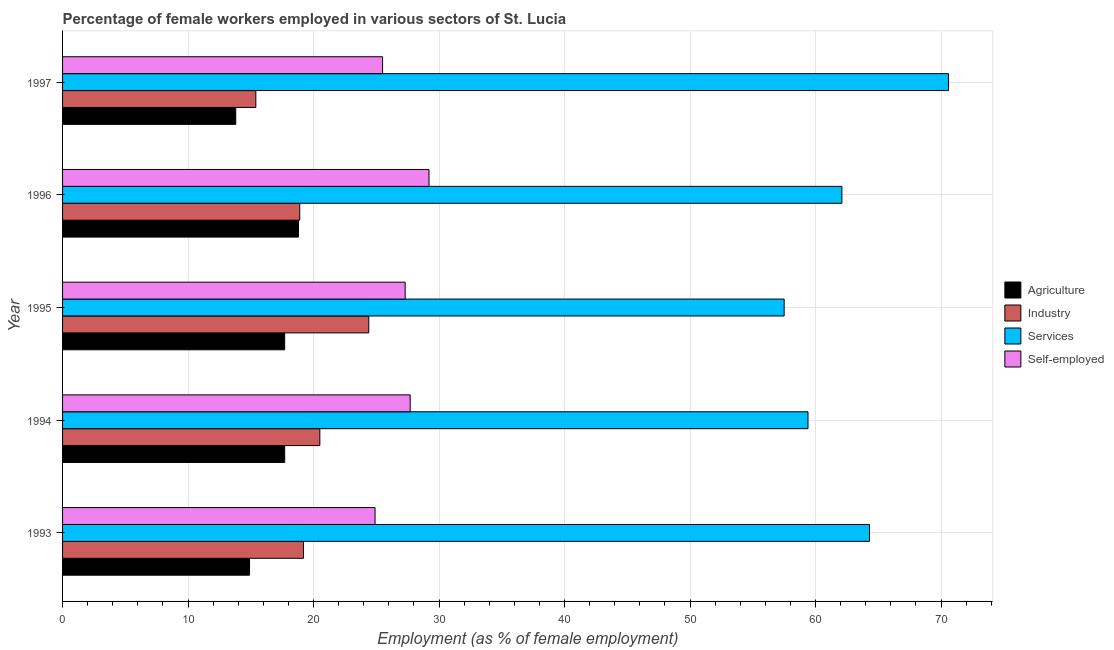How many different coloured bars are there?
Provide a succinct answer. 4. How many groups of bars are there?
Keep it short and to the point. 5. Are the number of bars on each tick of the Y-axis equal?
Your answer should be very brief. Yes. What is the percentage of female workers in services in 1993?
Provide a short and direct response. 64.3. Across all years, what is the maximum percentage of female workers in industry?
Provide a succinct answer. 24.4. Across all years, what is the minimum percentage of female workers in services?
Ensure brevity in your answer.  57.5. In which year was the percentage of self employed female workers maximum?
Your response must be concise. 1996. In which year was the percentage of self employed female workers minimum?
Ensure brevity in your answer.  1993. What is the total percentage of female workers in industry in the graph?
Offer a terse response. 98.4. What is the average percentage of female workers in agriculture per year?
Your response must be concise. 16.58. In the year 1993, what is the difference between the percentage of female workers in services and percentage of female workers in agriculture?
Provide a succinct answer. 49.4. In how many years, is the percentage of female workers in services greater than 40 %?
Your answer should be compact. 5. What is the ratio of the percentage of female workers in industry in 1994 to that in 1995?
Provide a succinct answer. 0.84. Is the percentage of self employed female workers in 1993 less than that in 1994?
Provide a succinct answer. Yes. Is the difference between the percentage of female workers in agriculture in 1993 and 1996 greater than the difference between the percentage of self employed female workers in 1993 and 1996?
Provide a succinct answer. Yes. What is the difference between the highest and the lowest percentage of self employed female workers?
Give a very brief answer. 4.3. In how many years, is the percentage of female workers in services greater than the average percentage of female workers in services taken over all years?
Provide a short and direct response. 2. Is the sum of the percentage of self employed female workers in 1994 and 1996 greater than the maximum percentage of female workers in agriculture across all years?
Give a very brief answer. Yes. Is it the case that in every year, the sum of the percentage of female workers in services and percentage of female workers in agriculture is greater than the sum of percentage of female workers in industry and percentage of self employed female workers?
Give a very brief answer. Yes. What does the 4th bar from the top in 1994 represents?
Offer a very short reply. Agriculture. What does the 2nd bar from the bottom in 1995 represents?
Offer a very short reply. Industry. Is it the case that in every year, the sum of the percentage of female workers in agriculture and percentage of female workers in industry is greater than the percentage of female workers in services?
Your response must be concise. No. How many bars are there?
Ensure brevity in your answer.  20. How many years are there in the graph?
Provide a short and direct response. 5. What is the difference between two consecutive major ticks on the X-axis?
Your response must be concise. 10. Are the values on the major ticks of X-axis written in scientific E-notation?
Provide a short and direct response. No. Does the graph contain grids?
Provide a succinct answer. Yes. Where does the legend appear in the graph?
Ensure brevity in your answer.  Center right. How many legend labels are there?
Keep it short and to the point. 4. How are the legend labels stacked?
Your response must be concise. Vertical. What is the title of the graph?
Offer a very short reply. Percentage of female workers employed in various sectors of St. Lucia. Does "Tracking ability" appear as one of the legend labels in the graph?
Give a very brief answer. No. What is the label or title of the X-axis?
Your answer should be compact. Employment (as % of female employment). What is the label or title of the Y-axis?
Ensure brevity in your answer.  Year. What is the Employment (as % of female employment) of Agriculture in 1993?
Provide a succinct answer. 14.9. What is the Employment (as % of female employment) in Industry in 1993?
Give a very brief answer. 19.2. What is the Employment (as % of female employment) of Services in 1993?
Offer a very short reply. 64.3. What is the Employment (as % of female employment) in Self-employed in 1993?
Give a very brief answer. 24.9. What is the Employment (as % of female employment) of Agriculture in 1994?
Your answer should be compact. 17.7. What is the Employment (as % of female employment) of Services in 1994?
Provide a succinct answer. 59.4. What is the Employment (as % of female employment) in Self-employed in 1994?
Keep it short and to the point. 27.7. What is the Employment (as % of female employment) of Agriculture in 1995?
Make the answer very short. 17.7. What is the Employment (as % of female employment) in Industry in 1995?
Provide a short and direct response. 24.4. What is the Employment (as % of female employment) in Services in 1995?
Give a very brief answer. 57.5. What is the Employment (as % of female employment) in Self-employed in 1995?
Give a very brief answer. 27.3. What is the Employment (as % of female employment) of Agriculture in 1996?
Provide a succinct answer. 18.8. What is the Employment (as % of female employment) of Industry in 1996?
Offer a very short reply. 18.9. What is the Employment (as % of female employment) in Services in 1996?
Give a very brief answer. 62.1. What is the Employment (as % of female employment) of Self-employed in 1996?
Ensure brevity in your answer.  29.2. What is the Employment (as % of female employment) in Agriculture in 1997?
Keep it short and to the point. 13.8. What is the Employment (as % of female employment) of Industry in 1997?
Ensure brevity in your answer.  15.4. What is the Employment (as % of female employment) in Services in 1997?
Your answer should be compact. 70.6. What is the Employment (as % of female employment) of Self-employed in 1997?
Ensure brevity in your answer.  25.5. Across all years, what is the maximum Employment (as % of female employment) in Agriculture?
Your answer should be compact. 18.8. Across all years, what is the maximum Employment (as % of female employment) in Industry?
Make the answer very short. 24.4. Across all years, what is the maximum Employment (as % of female employment) in Services?
Offer a terse response. 70.6. Across all years, what is the maximum Employment (as % of female employment) in Self-employed?
Offer a very short reply. 29.2. Across all years, what is the minimum Employment (as % of female employment) of Agriculture?
Ensure brevity in your answer.  13.8. Across all years, what is the minimum Employment (as % of female employment) in Industry?
Make the answer very short. 15.4. Across all years, what is the minimum Employment (as % of female employment) of Services?
Ensure brevity in your answer.  57.5. Across all years, what is the minimum Employment (as % of female employment) of Self-employed?
Ensure brevity in your answer.  24.9. What is the total Employment (as % of female employment) in Agriculture in the graph?
Your answer should be very brief. 82.9. What is the total Employment (as % of female employment) in Industry in the graph?
Offer a terse response. 98.4. What is the total Employment (as % of female employment) in Services in the graph?
Offer a terse response. 313.9. What is the total Employment (as % of female employment) in Self-employed in the graph?
Give a very brief answer. 134.6. What is the difference between the Employment (as % of female employment) in Agriculture in 1993 and that in 1994?
Your answer should be very brief. -2.8. What is the difference between the Employment (as % of female employment) of Services in 1993 and that in 1994?
Your answer should be very brief. 4.9. What is the difference between the Employment (as % of female employment) in Self-employed in 1993 and that in 1994?
Keep it short and to the point. -2.8. What is the difference between the Employment (as % of female employment) of Industry in 1993 and that in 1995?
Provide a short and direct response. -5.2. What is the difference between the Employment (as % of female employment) in Services in 1993 and that in 1995?
Your response must be concise. 6.8. What is the difference between the Employment (as % of female employment) in Self-employed in 1993 and that in 1995?
Offer a terse response. -2.4. What is the difference between the Employment (as % of female employment) of Agriculture in 1993 and that in 1996?
Your answer should be very brief. -3.9. What is the difference between the Employment (as % of female employment) in Services in 1993 and that in 1996?
Your response must be concise. 2.2. What is the difference between the Employment (as % of female employment) of Self-employed in 1993 and that in 1996?
Offer a very short reply. -4.3. What is the difference between the Employment (as % of female employment) in Agriculture in 1993 and that in 1997?
Your response must be concise. 1.1. What is the difference between the Employment (as % of female employment) of Services in 1993 and that in 1997?
Make the answer very short. -6.3. What is the difference between the Employment (as % of female employment) of Self-employed in 1993 and that in 1997?
Your answer should be compact. -0.6. What is the difference between the Employment (as % of female employment) in Industry in 1994 and that in 1995?
Keep it short and to the point. -3.9. What is the difference between the Employment (as % of female employment) of Services in 1994 and that in 1995?
Give a very brief answer. 1.9. What is the difference between the Employment (as % of female employment) of Self-employed in 1994 and that in 1995?
Your response must be concise. 0.4. What is the difference between the Employment (as % of female employment) in Agriculture in 1994 and that in 1996?
Your answer should be very brief. -1.1. What is the difference between the Employment (as % of female employment) of Industry in 1994 and that in 1996?
Ensure brevity in your answer.  1.6. What is the difference between the Employment (as % of female employment) of Agriculture in 1994 and that in 1997?
Ensure brevity in your answer.  3.9. What is the difference between the Employment (as % of female employment) of Industry in 1994 and that in 1997?
Your answer should be compact. 5.1. What is the difference between the Employment (as % of female employment) in Services in 1994 and that in 1997?
Offer a terse response. -11.2. What is the difference between the Employment (as % of female employment) of Self-employed in 1994 and that in 1997?
Provide a succinct answer. 2.2. What is the difference between the Employment (as % of female employment) of Agriculture in 1995 and that in 1996?
Your answer should be compact. -1.1. What is the difference between the Employment (as % of female employment) of Services in 1995 and that in 1996?
Offer a very short reply. -4.6. What is the difference between the Employment (as % of female employment) in Agriculture in 1995 and that in 1997?
Provide a short and direct response. 3.9. What is the difference between the Employment (as % of female employment) of Agriculture in 1993 and the Employment (as % of female employment) of Industry in 1994?
Your answer should be very brief. -5.6. What is the difference between the Employment (as % of female employment) of Agriculture in 1993 and the Employment (as % of female employment) of Services in 1994?
Your answer should be compact. -44.5. What is the difference between the Employment (as % of female employment) of Industry in 1993 and the Employment (as % of female employment) of Services in 1994?
Ensure brevity in your answer.  -40.2. What is the difference between the Employment (as % of female employment) of Industry in 1993 and the Employment (as % of female employment) of Self-employed in 1994?
Keep it short and to the point. -8.5. What is the difference between the Employment (as % of female employment) in Services in 1993 and the Employment (as % of female employment) in Self-employed in 1994?
Your answer should be very brief. 36.6. What is the difference between the Employment (as % of female employment) in Agriculture in 1993 and the Employment (as % of female employment) in Industry in 1995?
Give a very brief answer. -9.5. What is the difference between the Employment (as % of female employment) of Agriculture in 1993 and the Employment (as % of female employment) of Services in 1995?
Your answer should be compact. -42.6. What is the difference between the Employment (as % of female employment) in Industry in 1993 and the Employment (as % of female employment) in Services in 1995?
Offer a very short reply. -38.3. What is the difference between the Employment (as % of female employment) in Services in 1993 and the Employment (as % of female employment) in Self-employed in 1995?
Provide a short and direct response. 37. What is the difference between the Employment (as % of female employment) in Agriculture in 1993 and the Employment (as % of female employment) in Industry in 1996?
Ensure brevity in your answer.  -4. What is the difference between the Employment (as % of female employment) in Agriculture in 1993 and the Employment (as % of female employment) in Services in 1996?
Keep it short and to the point. -47.2. What is the difference between the Employment (as % of female employment) in Agriculture in 1993 and the Employment (as % of female employment) in Self-employed in 1996?
Make the answer very short. -14.3. What is the difference between the Employment (as % of female employment) in Industry in 1993 and the Employment (as % of female employment) in Services in 1996?
Make the answer very short. -42.9. What is the difference between the Employment (as % of female employment) in Industry in 1993 and the Employment (as % of female employment) in Self-employed in 1996?
Offer a very short reply. -10. What is the difference between the Employment (as % of female employment) of Services in 1993 and the Employment (as % of female employment) of Self-employed in 1996?
Your answer should be compact. 35.1. What is the difference between the Employment (as % of female employment) in Agriculture in 1993 and the Employment (as % of female employment) in Services in 1997?
Provide a succinct answer. -55.7. What is the difference between the Employment (as % of female employment) of Agriculture in 1993 and the Employment (as % of female employment) of Self-employed in 1997?
Your answer should be very brief. -10.6. What is the difference between the Employment (as % of female employment) in Industry in 1993 and the Employment (as % of female employment) in Services in 1997?
Ensure brevity in your answer.  -51.4. What is the difference between the Employment (as % of female employment) in Industry in 1993 and the Employment (as % of female employment) in Self-employed in 1997?
Keep it short and to the point. -6.3. What is the difference between the Employment (as % of female employment) in Services in 1993 and the Employment (as % of female employment) in Self-employed in 1997?
Your answer should be very brief. 38.8. What is the difference between the Employment (as % of female employment) of Agriculture in 1994 and the Employment (as % of female employment) of Industry in 1995?
Offer a terse response. -6.7. What is the difference between the Employment (as % of female employment) of Agriculture in 1994 and the Employment (as % of female employment) of Services in 1995?
Offer a very short reply. -39.8. What is the difference between the Employment (as % of female employment) of Industry in 1994 and the Employment (as % of female employment) of Services in 1995?
Provide a succinct answer. -37. What is the difference between the Employment (as % of female employment) of Services in 1994 and the Employment (as % of female employment) of Self-employed in 1995?
Your response must be concise. 32.1. What is the difference between the Employment (as % of female employment) of Agriculture in 1994 and the Employment (as % of female employment) of Services in 1996?
Provide a succinct answer. -44.4. What is the difference between the Employment (as % of female employment) of Agriculture in 1994 and the Employment (as % of female employment) of Self-employed in 1996?
Ensure brevity in your answer.  -11.5. What is the difference between the Employment (as % of female employment) of Industry in 1994 and the Employment (as % of female employment) of Services in 1996?
Offer a terse response. -41.6. What is the difference between the Employment (as % of female employment) of Services in 1994 and the Employment (as % of female employment) of Self-employed in 1996?
Ensure brevity in your answer.  30.2. What is the difference between the Employment (as % of female employment) of Agriculture in 1994 and the Employment (as % of female employment) of Services in 1997?
Keep it short and to the point. -52.9. What is the difference between the Employment (as % of female employment) in Industry in 1994 and the Employment (as % of female employment) in Services in 1997?
Make the answer very short. -50.1. What is the difference between the Employment (as % of female employment) of Industry in 1994 and the Employment (as % of female employment) of Self-employed in 1997?
Offer a terse response. -5. What is the difference between the Employment (as % of female employment) in Services in 1994 and the Employment (as % of female employment) in Self-employed in 1997?
Your answer should be compact. 33.9. What is the difference between the Employment (as % of female employment) of Agriculture in 1995 and the Employment (as % of female employment) of Services in 1996?
Ensure brevity in your answer.  -44.4. What is the difference between the Employment (as % of female employment) in Industry in 1995 and the Employment (as % of female employment) in Services in 1996?
Give a very brief answer. -37.7. What is the difference between the Employment (as % of female employment) of Services in 1995 and the Employment (as % of female employment) of Self-employed in 1996?
Your answer should be very brief. 28.3. What is the difference between the Employment (as % of female employment) in Agriculture in 1995 and the Employment (as % of female employment) in Industry in 1997?
Your answer should be very brief. 2.3. What is the difference between the Employment (as % of female employment) of Agriculture in 1995 and the Employment (as % of female employment) of Services in 1997?
Provide a succinct answer. -52.9. What is the difference between the Employment (as % of female employment) of Agriculture in 1995 and the Employment (as % of female employment) of Self-employed in 1997?
Keep it short and to the point. -7.8. What is the difference between the Employment (as % of female employment) in Industry in 1995 and the Employment (as % of female employment) in Services in 1997?
Your answer should be compact. -46.2. What is the difference between the Employment (as % of female employment) of Agriculture in 1996 and the Employment (as % of female employment) of Services in 1997?
Your answer should be compact. -51.8. What is the difference between the Employment (as % of female employment) of Industry in 1996 and the Employment (as % of female employment) of Services in 1997?
Ensure brevity in your answer.  -51.7. What is the difference between the Employment (as % of female employment) in Services in 1996 and the Employment (as % of female employment) in Self-employed in 1997?
Your response must be concise. 36.6. What is the average Employment (as % of female employment) of Agriculture per year?
Make the answer very short. 16.58. What is the average Employment (as % of female employment) in Industry per year?
Give a very brief answer. 19.68. What is the average Employment (as % of female employment) in Services per year?
Your response must be concise. 62.78. What is the average Employment (as % of female employment) of Self-employed per year?
Your answer should be very brief. 26.92. In the year 1993, what is the difference between the Employment (as % of female employment) in Agriculture and Employment (as % of female employment) in Services?
Keep it short and to the point. -49.4. In the year 1993, what is the difference between the Employment (as % of female employment) in Agriculture and Employment (as % of female employment) in Self-employed?
Your answer should be very brief. -10. In the year 1993, what is the difference between the Employment (as % of female employment) in Industry and Employment (as % of female employment) in Services?
Provide a succinct answer. -45.1. In the year 1993, what is the difference between the Employment (as % of female employment) of Services and Employment (as % of female employment) of Self-employed?
Offer a very short reply. 39.4. In the year 1994, what is the difference between the Employment (as % of female employment) of Agriculture and Employment (as % of female employment) of Services?
Offer a terse response. -41.7. In the year 1994, what is the difference between the Employment (as % of female employment) in Industry and Employment (as % of female employment) in Services?
Offer a very short reply. -38.9. In the year 1994, what is the difference between the Employment (as % of female employment) of Industry and Employment (as % of female employment) of Self-employed?
Give a very brief answer. -7.2. In the year 1994, what is the difference between the Employment (as % of female employment) of Services and Employment (as % of female employment) of Self-employed?
Keep it short and to the point. 31.7. In the year 1995, what is the difference between the Employment (as % of female employment) of Agriculture and Employment (as % of female employment) of Industry?
Give a very brief answer. -6.7. In the year 1995, what is the difference between the Employment (as % of female employment) in Agriculture and Employment (as % of female employment) in Services?
Make the answer very short. -39.8. In the year 1995, what is the difference between the Employment (as % of female employment) in Agriculture and Employment (as % of female employment) in Self-employed?
Provide a succinct answer. -9.6. In the year 1995, what is the difference between the Employment (as % of female employment) of Industry and Employment (as % of female employment) of Services?
Give a very brief answer. -33.1. In the year 1995, what is the difference between the Employment (as % of female employment) in Industry and Employment (as % of female employment) in Self-employed?
Your response must be concise. -2.9. In the year 1995, what is the difference between the Employment (as % of female employment) of Services and Employment (as % of female employment) of Self-employed?
Your response must be concise. 30.2. In the year 1996, what is the difference between the Employment (as % of female employment) of Agriculture and Employment (as % of female employment) of Services?
Provide a succinct answer. -43.3. In the year 1996, what is the difference between the Employment (as % of female employment) in Agriculture and Employment (as % of female employment) in Self-employed?
Ensure brevity in your answer.  -10.4. In the year 1996, what is the difference between the Employment (as % of female employment) of Industry and Employment (as % of female employment) of Services?
Provide a succinct answer. -43.2. In the year 1996, what is the difference between the Employment (as % of female employment) of Services and Employment (as % of female employment) of Self-employed?
Your answer should be very brief. 32.9. In the year 1997, what is the difference between the Employment (as % of female employment) of Agriculture and Employment (as % of female employment) of Industry?
Make the answer very short. -1.6. In the year 1997, what is the difference between the Employment (as % of female employment) in Agriculture and Employment (as % of female employment) in Services?
Your response must be concise. -56.8. In the year 1997, what is the difference between the Employment (as % of female employment) of Agriculture and Employment (as % of female employment) of Self-employed?
Ensure brevity in your answer.  -11.7. In the year 1997, what is the difference between the Employment (as % of female employment) of Industry and Employment (as % of female employment) of Services?
Your response must be concise. -55.2. In the year 1997, what is the difference between the Employment (as % of female employment) in Services and Employment (as % of female employment) in Self-employed?
Your response must be concise. 45.1. What is the ratio of the Employment (as % of female employment) in Agriculture in 1993 to that in 1994?
Make the answer very short. 0.84. What is the ratio of the Employment (as % of female employment) in Industry in 1993 to that in 1994?
Ensure brevity in your answer.  0.94. What is the ratio of the Employment (as % of female employment) in Services in 1993 to that in 1994?
Offer a terse response. 1.08. What is the ratio of the Employment (as % of female employment) of Self-employed in 1993 to that in 1994?
Your answer should be very brief. 0.9. What is the ratio of the Employment (as % of female employment) of Agriculture in 1993 to that in 1995?
Keep it short and to the point. 0.84. What is the ratio of the Employment (as % of female employment) of Industry in 1993 to that in 1995?
Give a very brief answer. 0.79. What is the ratio of the Employment (as % of female employment) of Services in 1993 to that in 1995?
Your answer should be compact. 1.12. What is the ratio of the Employment (as % of female employment) in Self-employed in 1993 to that in 1995?
Your answer should be compact. 0.91. What is the ratio of the Employment (as % of female employment) in Agriculture in 1993 to that in 1996?
Ensure brevity in your answer.  0.79. What is the ratio of the Employment (as % of female employment) of Industry in 1993 to that in 1996?
Keep it short and to the point. 1.02. What is the ratio of the Employment (as % of female employment) in Services in 1993 to that in 1996?
Provide a short and direct response. 1.04. What is the ratio of the Employment (as % of female employment) in Self-employed in 1993 to that in 1996?
Keep it short and to the point. 0.85. What is the ratio of the Employment (as % of female employment) in Agriculture in 1993 to that in 1997?
Make the answer very short. 1.08. What is the ratio of the Employment (as % of female employment) of Industry in 1993 to that in 1997?
Ensure brevity in your answer.  1.25. What is the ratio of the Employment (as % of female employment) in Services in 1993 to that in 1997?
Make the answer very short. 0.91. What is the ratio of the Employment (as % of female employment) of Self-employed in 1993 to that in 1997?
Your answer should be compact. 0.98. What is the ratio of the Employment (as % of female employment) of Agriculture in 1994 to that in 1995?
Your answer should be compact. 1. What is the ratio of the Employment (as % of female employment) in Industry in 1994 to that in 1995?
Make the answer very short. 0.84. What is the ratio of the Employment (as % of female employment) in Services in 1994 to that in 1995?
Your answer should be very brief. 1.03. What is the ratio of the Employment (as % of female employment) of Self-employed in 1994 to that in 1995?
Give a very brief answer. 1.01. What is the ratio of the Employment (as % of female employment) of Agriculture in 1994 to that in 1996?
Your response must be concise. 0.94. What is the ratio of the Employment (as % of female employment) in Industry in 1994 to that in 1996?
Offer a very short reply. 1.08. What is the ratio of the Employment (as % of female employment) in Services in 1994 to that in 1996?
Make the answer very short. 0.96. What is the ratio of the Employment (as % of female employment) of Self-employed in 1994 to that in 1996?
Ensure brevity in your answer.  0.95. What is the ratio of the Employment (as % of female employment) of Agriculture in 1994 to that in 1997?
Your answer should be very brief. 1.28. What is the ratio of the Employment (as % of female employment) of Industry in 1994 to that in 1997?
Your answer should be compact. 1.33. What is the ratio of the Employment (as % of female employment) in Services in 1994 to that in 1997?
Your answer should be very brief. 0.84. What is the ratio of the Employment (as % of female employment) in Self-employed in 1994 to that in 1997?
Ensure brevity in your answer.  1.09. What is the ratio of the Employment (as % of female employment) of Agriculture in 1995 to that in 1996?
Your answer should be compact. 0.94. What is the ratio of the Employment (as % of female employment) in Industry in 1995 to that in 1996?
Keep it short and to the point. 1.29. What is the ratio of the Employment (as % of female employment) of Services in 1995 to that in 1996?
Keep it short and to the point. 0.93. What is the ratio of the Employment (as % of female employment) in Self-employed in 1995 to that in 1996?
Keep it short and to the point. 0.93. What is the ratio of the Employment (as % of female employment) in Agriculture in 1995 to that in 1997?
Give a very brief answer. 1.28. What is the ratio of the Employment (as % of female employment) of Industry in 1995 to that in 1997?
Ensure brevity in your answer.  1.58. What is the ratio of the Employment (as % of female employment) of Services in 1995 to that in 1997?
Give a very brief answer. 0.81. What is the ratio of the Employment (as % of female employment) in Self-employed in 1995 to that in 1997?
Your answer should be very brief. 1.07. What is the ratio of the Employment (as % of female employment) in Agriculture in 1996 to that in 1997?
Your answer should be very brief. 1.36. What is the ratio of the Employment (as % of female employment) of Industry in 1996 to that in 1997?
Offer a terse response. 1.23. What is the ratio of the Employment (as % of female employment) of Services in 1996 to that in 1997?
Offer a terse response. 0.88. What is the ratio of the Employment (as % of female employment) of Self-employed in 1996 to that in 1997?
Make the answer very short. 1.15. What is the difference between the highest and the second highest Employment (as % of female employment) of Services?
Your answer should be compact. 6.3. What is the difference between the highest and the second highest Employment (as % of female employment) of Self-employed?
Provide a succinct answer. 1.5. What is the difference between the highest and the lowest Employment (as % of female employment) in Agriculture?
Ensure brevity in your answer.  5. What is the difference between the highest and the lowest Employment (as % of female employment) in Industry?
Your answer should be very brief. 9. What is the difference between the highest and the lowest Employment (as % of female employment) in Services?
Offer a very short reply. 13.1. 